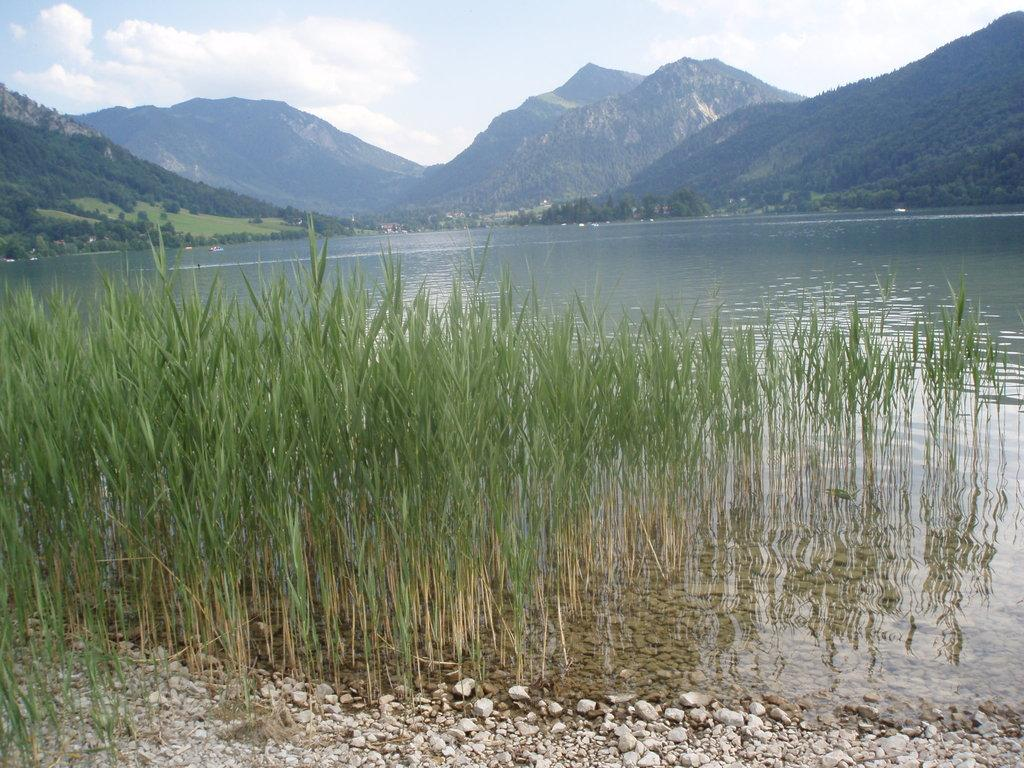What type of natural elements can be seen in the image? There are stones, water, and plants visible in the image. What can be seen in the background of the image? Hills and the sky are visible in the background of the image. What is the condition of the sky in the image? Clouds are present in the sky in the image. What type of furniture can be seen in the image? There is no furniture present in the image; it features natural elements such as stones, water, plants, hills, and the sky. Can you tell me how many carriages are visible in the image? There are no carriages present in the image. 